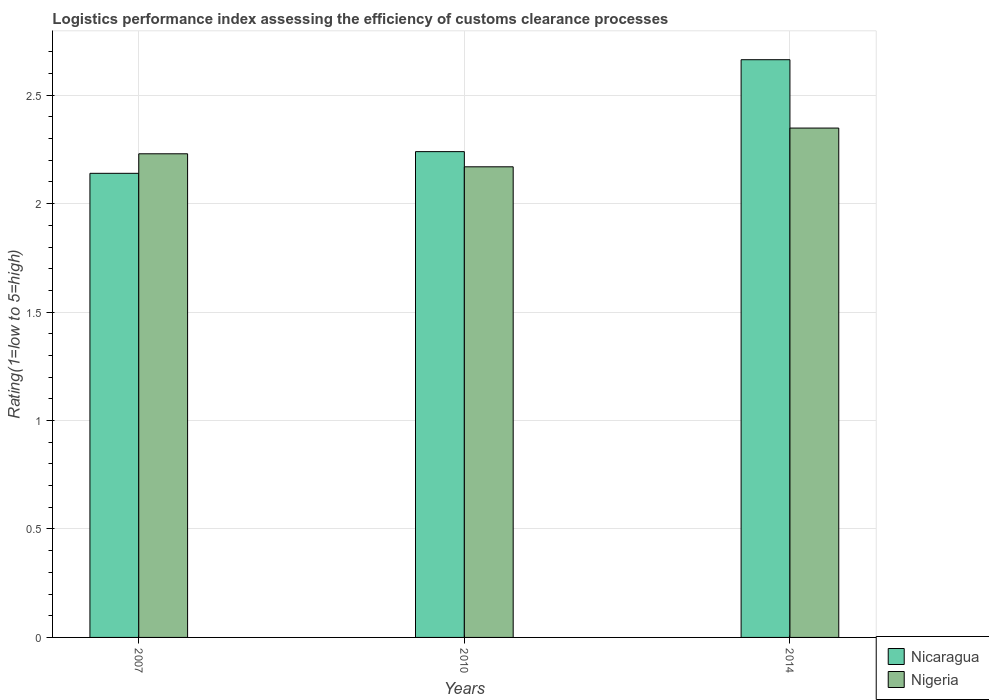How many different coloured bars are there?
Your answer should be compact. 2. How many groups of bars are there?
Offer a very short reply. 3. How many bars are there on the 2nd tick from the left?
Make the answer very short. 2. How many bars are there on the 2nd tick from the right?
Offer a terse response. 2. What is the label of the 1st group of bars from the left?
Provide a short and direct response. 2007. What is the Logistic performance index in Nigeria in 2007?
Your answer should be compact. 2.23. Across all years, what is the maximum Logistic performance index in Nicaragua?
Make the answer very short. 2.66. Across all years, what is the minimum Logistic performance index in Nicaragua?
Offer a terse response. 2.14. In which year was the Logistic performance index in Nicaragua maximum?
Make the answer very short. 2014. In which year was the Logistic performance index in Nicaragua minimum?
Your answer should be very brief. 2007. What is the total Logistic performance index in Nigeria in the graph?
Make the answer very short. 6.75. What is the difference between the Logistic performance index in Nigeria in 2007 and that in 2014?
Your answer should be very brief. -0.12. What is the difference between the Logistic performance index in Nigeria in 2007 and the Logistic performance index in Nicaragua in 2010?
Your answer should be very brief. -0.01. What is the average Logistic performance index in Nicaragua per year?
Your answer should be very brief. 2.35. In the year 2014, what is the difference between the Logistic performance index in Nicaragua and Logistic performance index in Nigeria?
Your answer should be very brief. 0.32. What is the ratio of the Logistic performance index in Nicaragua in 2007 to that in 2014?
Ensure brevity in your answer.  0.8. Is the Logistic performance index in Nicaragua in 2007 less than that in 2014?
Your response must be concise. Yes. Is the difference between the Logistic performance index in Nicaragua in 2007 and 2010 greater than the difference between the Logistic performance index in Nigeria in 2007 and 2010?
Keep it short and to the point. No. What is the difference between the highest and the second highest Logistic performance index in Nigeria?
Offer a terse response. 0.12. What is the difference between the highest and the lowest Logistic performance index in Nicaragua?
Your response must be concise. 0.52. Is the sum of the Logistic performance index in Nicaragua in 2010 and 2014 greater than the maximum Logistic performance index in Nigeria across all years?
Your answer should be compact. Yes. What does the 2nd bar from the left in 2014 represents?
Offer a terse response. Nigeria. What does the 1st bar from the right in 2014 represents?
Give a very brief answer. Nigeria. How many bars are there?
Your answer should be very brief. 6. How many years are there in the graph?
Provide a succinct answer. 3. Are the values on the major ticks of Y-axis written in scientific E-notation?
Provide a short and direct response. No. Does the graph contain any zero values?
Give a very brief answer. No. Does the graph contain grids?
Provide a succinct answer. Yes. How many legend labels are there?
Give a very brief answer. 2. What is the title of the graph?
Your response must be concise. Logistics performance index assessing the efficiency of customs clearance processes. Does "Kiribati" appear as one of the legend labels in the graph?
Offer a very short reply. No. What is the label or title of the Y-axis?
Provide a short and direct response. Rating(1=low to 5=high). What is the Rating(1=low to 5=high) of Nicaragua in 2007?
Make the answer very short. 2.14. What is the Rating(1=low to 5=high) in Nigeria in 2007?
Keep it short and to the point. 2.23. What is the Rating(1=low to 5=high) of Nicaragua in 2010?
Give a very brief answer. 2.24. What is the Rating(1=low to 5=high) in Nigeria in 2010?
Keep it short and to the point. 2.17. What is the Rating(1=low to 5=high) in Nicaragua in 2014?
Keep it short and to the point. 2.66. What is the Rating(1=low to 5=high) in Nigeria in 2014?
Ensure brevity in your answer.  2.35. Across all years, what is the maximum Rating(1=low to 5=high) in Nicaragua?
Your response must be concise. 2.66. Across all years, what is the maximum Rating(1=low to 5=high) in Nigeria?
Provide a short and direct response. 2.35. Across all years, what is the minimum Rating(1=low to 5=high) in Nicaragua?
Your response must be concise. 2.14. Across all years, what is the minimum Rating(1=low to 5=high) in Nigeria?
Your response must be concise. 2.17. What is the total Rating(1=low to 5=high) of Nicaragua in the graph?
Your answer should be very brief. 7.04. What is the total Rating(1=low to 5=high) in Nigeria in the graph?
Provide a succinct answer. 6.75. What is the difference between the Rating(1=low to 5=high) of Nicaragua in 2007 and that in 2010?
Provide a succinct answer. -0.1. What is the difference between the Rating(1=low to 5=high) in Nigeria in 2007 and that in 2010?
Keep it short and to the point. 0.06. What is the difference between the Rating(1=low to 5=high) in Nicaragua in 2007 and that in 2014?
Offer a very short reply. -0.52. What is the difference between the Rating(1=low to 5=high) of Nigeria in 2007 and that in 2014?
Your answer should be compact. -0.12. What is the difference between the Rating(1=low to 5=high) of Nicaragua in 2010 and that in 2014?
Give a very brief answer. -0.42. What is the difference between the Rating(1=low to 5=high) of Nigeria in 2010 and that in 2014?
Offer a very short reply. -0.18. What is the difference between the Rating(1=low to 5=high) in Nicaragua in 2007 and the Rating(1=low to 5=high) in Nigeria in 2010?
Make the answer very short. -0.03. What is the difference between the Rating(1=low to 5=high) of Nicaragua in 2007 and the Rating(1=low to 5=high) of Nigeria in 2014?
Ensure brevity in your answer.  -0.21. What is the difference between the Rating(1=low to 5=high) of Nicaragua in 2010 and the Rating(1=low to 5=high) of Nigeria in 2014?
Your answer should be compact. -0.11. What is the average Rating(1=low to 5=high) in Nicaragua per year?
Ensure brevity in your answer.  2.35. What is the average Rating(1=low to 5=high) of Nigeria per year?
Provide a short and direct response. 2.25. In the year 2007, what is the difference between the Rating(1=low to 5=high) in Nicaragua and Rating(1=low to 5=high) in Nigeria?
Offer a very short reply. -0.09. In the year 2010, what is the difference between the Rating(1=low to 5=high) in Nicaragua and Rating(1=low to 5=high) in Nigeria?
Make the answer very short. 0.07. In the year 2014, what is the difference between the Rating(1=low to 5=high) of Nicaragua and Rating(1=low to 5=high) of Nigeria?
Your answer should be compact. 0.32. What is the ratio of the Rating(1=low to 5=high) in Nicaragua in 2007 to that in 2010?
Your answer should be very brief. 0.96. What is the ratio of the Rating(1=low to 5=high) in Nigeria in 2007 to that in 2010?
Provide a short and direct response. 1.03. What is the ratio of the Rating(1=low to 5=high) of Nicaragua in 2007 to that in 2014?
Your answer should be very brief. 0.8. What is the ratio of the Rating(1=low to 5=high) of Nigeria in 2007 to that in 2014?
Your answer should be very brief. 0.95. What is the ratio of the Rating(1=low to 5=high) of Nicaragua in 2010 to that in 2014?
Keep it short and to the point. 0.84. What is the ratio of the Rating(1=low to 5=high) in Nigeria in 2010 to that in 2014?
Make the answer very short. 0.92. What is the difference between the highest and the second highest Rating(1=low to 5=high) of Nicaragua?
Make the answer very short. 0.42. What is the difference between the highest and the second highest Rating(1=low to 5=high) of Nigeria?
Provide a short and direct response. 0.12. What is the difference between the highest and the lowest Rating(1=low to 5=high) in Nicaragua?
Offer a terse response. 0.52. What is the difference between the highest and the lowest Rating(1=low to 5=high) of Nigeria?
Make the answer very short. 0.18. 